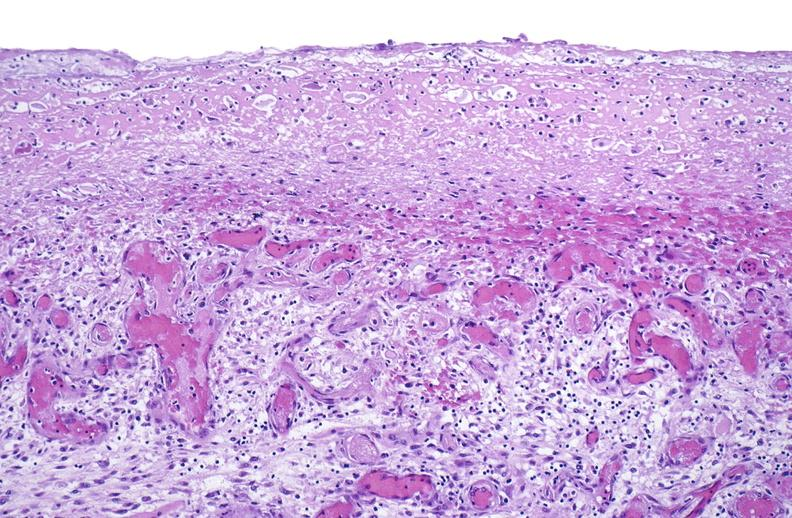does this image show tracheotomy site, granulation tissue?
Answer the question using a single word or phrase. Yes 